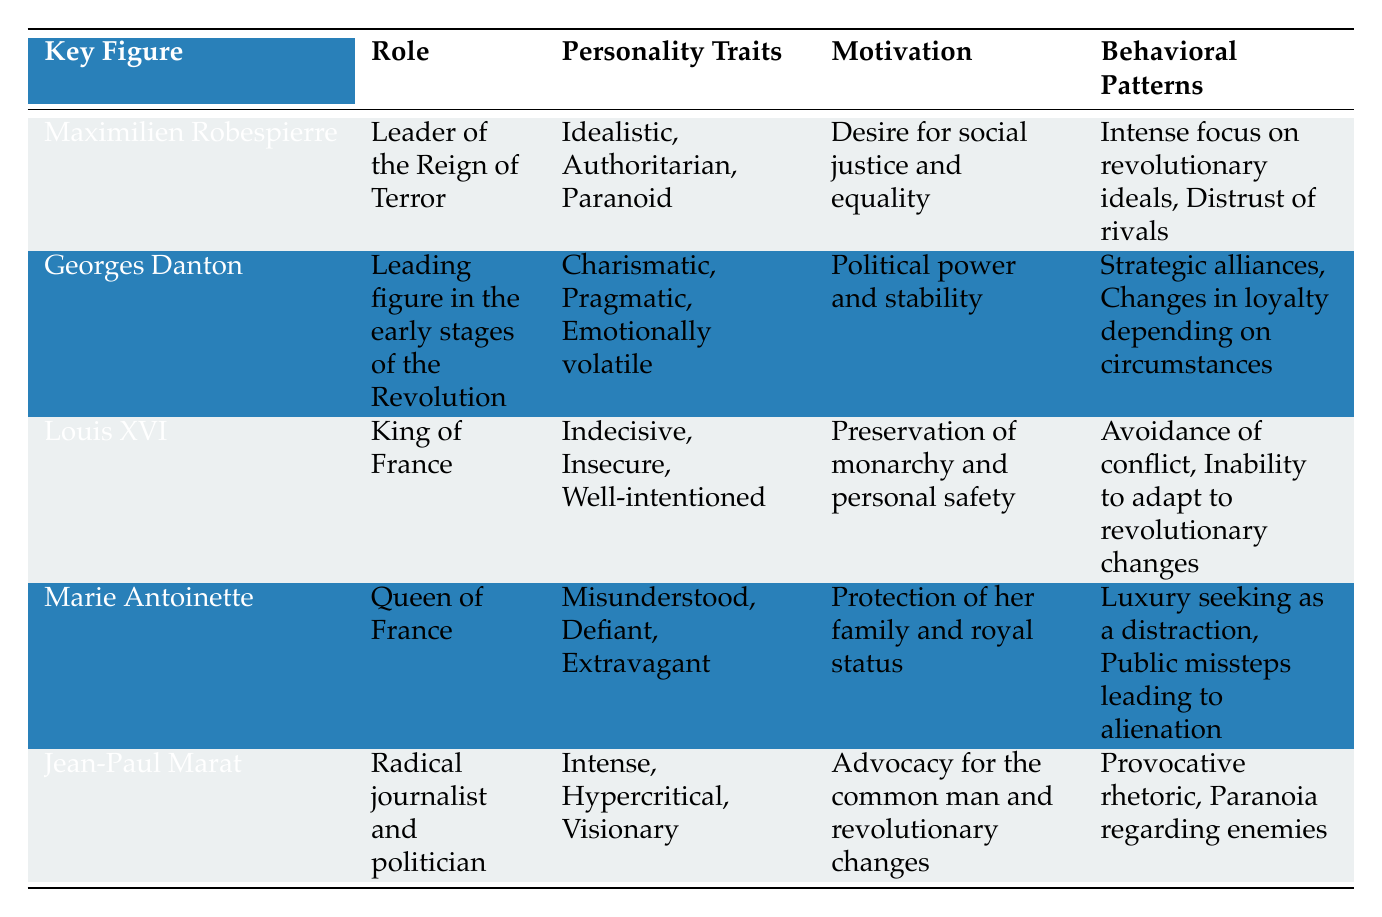What are the personality traits of Marie Antoinette? According to the table, Marie Antoinette has the personality traits of being Misunderstood, Defiant, and Extravagant. These traits are directly listed under her psychological profile.
Answer: Misunderstood, Defiant, Extravagant Who was the leader of the Reign of Terror? The table clearly states that Maximilien Robespierre was the Leader of the Reign of Terror.
Answer: Maximilien Robespierre Which key figure is described as Emotionally volatile? From the table, Georges Danton is identified as having the personality trait of being Emotionally volatile, noted under his psychological profile.
Answer: Georges Danton True or False: Louis XVI's motivation was the desire for social justice and equality. The table indicates that Louis XVI's motivation was the Preservation of monarchy and personal safety, not social justice and equality. Thus, the statement is false.
Answer: False What is the primary motivation for Jean-Paul Marat? The table specifies that Jean-Paul Marat's primary motivation was Advocacy for the common man and revolutionary changes. This is stated in the motivation column specifically for Marat.
Answer: Advocacy for the common man and revolutionary changes List the behavioral patterns associated with Maximilien Robespierre. The table outlines that Maximilien Robespierre's behavioral patterns include having an Intense focus on revolutionary ideals and a Distrust of rivals, which are found under his psychological profile.
Answer: Intense focus on revolutionary ideals, Distrust of rivals Which two key figures have 'Paranoia' mentioned in their psychological profiles? By analyzing the table, it can be seen that both Maximilien Robespierre and Jean-Paul Marat exhibit 'Paranoia' as part of their psychological profiles, demonstrated in their behavioral patterns.
Answer: Maximilien Robespierre, Jean-Paul Marat How many key figures had the role of a leader or monarch during the French Revolution? In the table, there are three figures associated with leadership positions: Maximilien Robespierre (Leader of the Reign of Terror), Georges Danton (Leading figure in the early stages), and Louis XVI (King of France). In total, there are three leaders or monarchs.
Answer: 3 What is the average number of personality traits listed for each key figure? There are five key figures mentioned, with a total of 14 unique personality traits across them (3 for Robespierre, 3 for Danton, 3 for Louis XVI, 3 for Marie Antoinette, and 3 for Marat; noting that some traits are repeated). Calculating the average gives 14 traits divided by 5 figures, yielding an average of 2.8 personality traits per key figure.
Answer: 2.8 